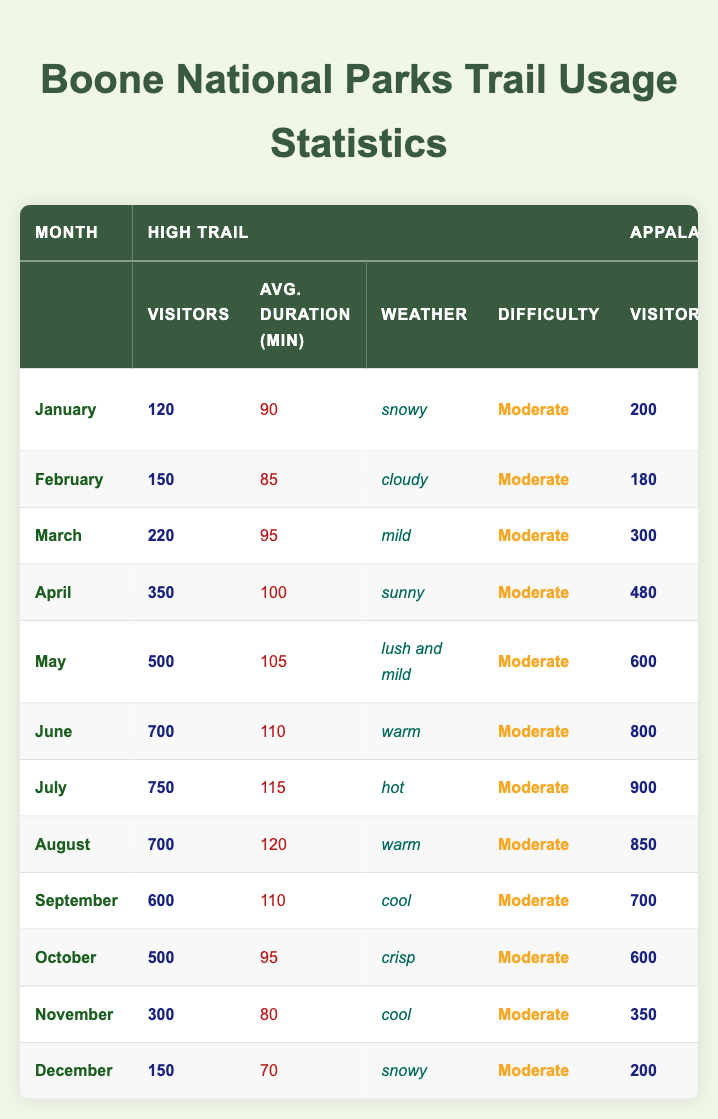What is the total number of visitors for all three trails in May? In May, the total visitors are 500 (High Trail) + 600 (Appalachian Trail) + 400 (Blue Ridge Trail) = 1500.
Answer: 1500 Which month had the highest average duration on the Appalachian Trail? The average durations for the Appalachian Trail are as follows: January (120), February (130), March (150), April (145), May (160), June (170), July (180), August (165), September (160), October (150), November (140), December (130). The highest is 180 in July.
Answer: July Did more visitors use the Blue Ridge Trail than the High Trail in January? In January, the High Trail had 120 visitors, and the Blue Ridge Trail had 90 visitors. Since 120 > 90, the statement is true.
Answer: Yes What is the average number of visitors on the High Trail throughout the year? The visitors on the High Trail by month are: 120, 150, 220, 350, 500, 700, 750, 700, 600, 500, 300, 150. Summing these gives 4050. Dividing by 12 months gives an average of 4050 / 12 = 337.5.
Answer: 337.5 Which trail had the most visitors in October? In October, the visitor counts are 500 (High Trail), 600 (Appalachian Trail), and 400 (Blue Ridge Trail). The most visitors were on the Appalachian Trail with 600.
Answer: Appalachian Trail Compare the average duration of the Blue Ridge Trail and High Trail in the month of June. In June, the Blue Ridge Trail had an average duration of 100 minutes, and the High Trail had 110 minutes. Since 110 > 100, the High Trail had a longer average duration.
Answer: High Trail What is the difference in visitors between the Appalachian Trail and High Trail in April? In April, the Appalachian Trail had 480 visitors, and the High Trail had 350 visitors. The difference is 480 - 350 = 130.
Answer: 130 In which month did the High Trail experience the lowest number of visitors? Looking at the monthly visitors: 120 (January), 150 (February), 220 (March), 350 (April), 500 (May), 700 (June), 750 (July), 700 (August), 600 (September), 500 (October), 300 (November), 150 (December), January had the lowest at 120.
Answer: January What weather condition corresponded with the highest visitor count for the High Trail? The highest visitor count for the High Trail was 750 in July, and the weather then was hot.
Answer: Hot If one wanted to hike the easiest trail, which one would it be and during what month had the lowest visitors? The easiest trail is the Blue Ridge Trail, which has a consistent easy difficulty rating. The month with the lowest visitors for Blue Ridge was January with 90 visitors.
Answer: Blue Ridge Trail in January 